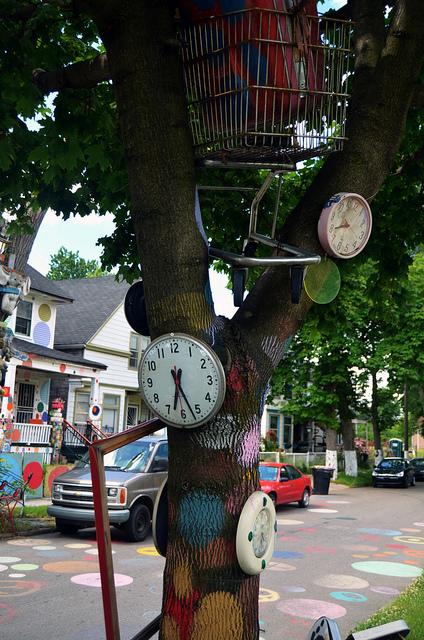What time is shown?
Short answer required. 6:27. Would this sculpture be described as rustic or modern?
Keep it brief. Modern. What's in between the two branches?
Short answer required. Shopping cart. Are any of the clocks telling the right time?
Short answer required. No. How many clocks are on the tree?
Short answer required. 3. 